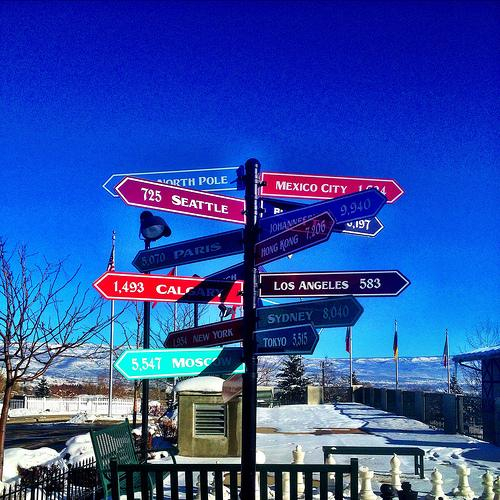How many objects in the image are associated with the term "a bight photo background"? There are 6 objects associated with the term "a bight photo background". Identify the color and type of the largest sky background in the image. The largest sky background is blue and of a cloud type. Explain the relationship between the street direction signs and the city names mentioned in the image. The street direction signs display the directions to various cities mentioned, such as Seattle, Moscow, Tokyo, Los Angeles, Paris, Mexico City, North Pole, and Hong Kong. These signs indicate the distance and orientation to each city from the viewer's perspective. What is the most prominent sentiment or emotion conveyed by the image? The sentiment conveyed by the image is a sense of adventure and travel, due to the presence of multiple city street signs. How many street signs are present in the image and which cities are mentioned on them? There are 9 street signs. Cities mentioned are Seattle, Moscow, Tokyo, Los Angeles, Paris, Mexico City, North Pole, and Hong Kong. Provide a simplified caption for the image with the main objects and their placements. An image with a blue sky background, street signs for multiple cities, green and black benches, a dry tree branch, rook chess piece, and several flags. What is the purpose of the image quality assessment task for this image? The purpose of the image quality assessment task is to evaluate the clarity, resolution, and overall quality of the visual information presented in the image. In the context of the image, how many objects can you count related to street signs on poles? There are 5 objects related to street signs on poles in the image. 